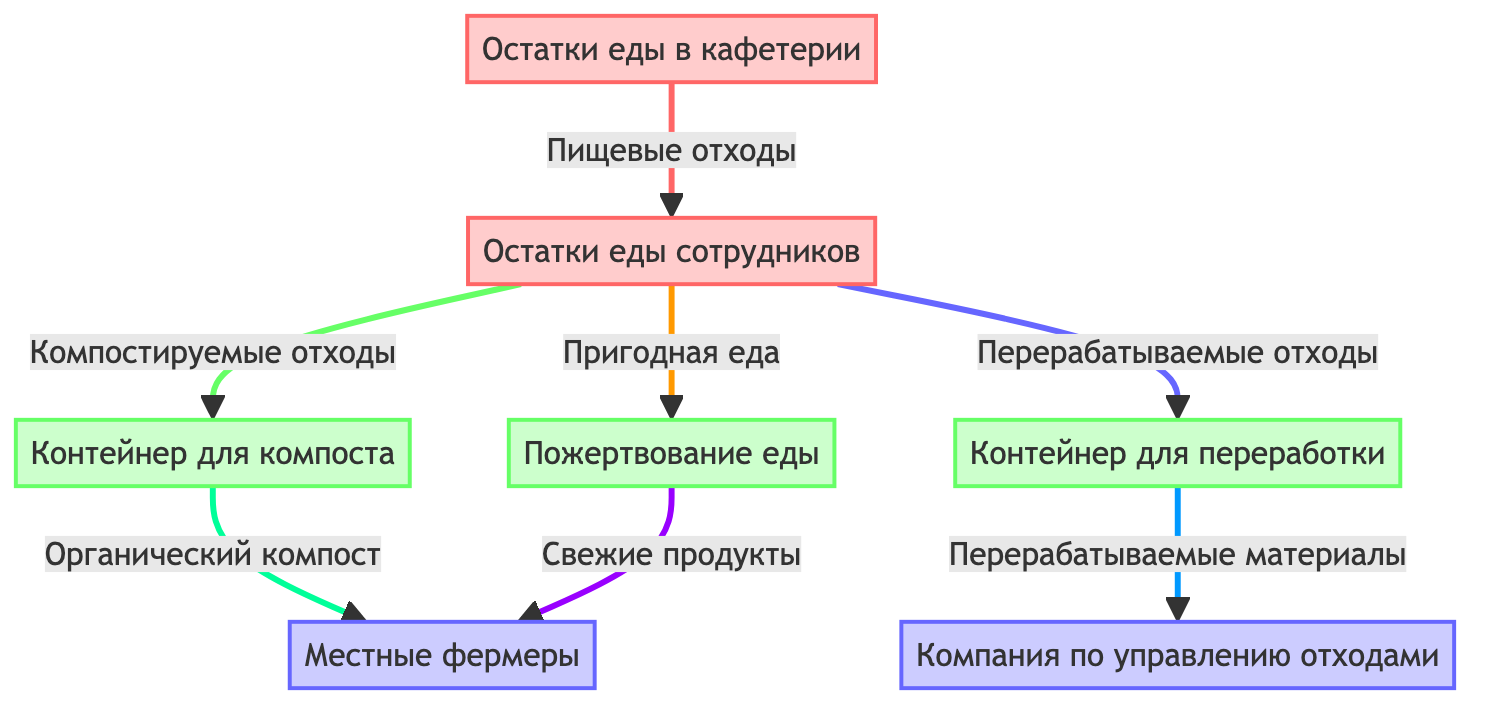What are the two main types of food waste in the diagram? The diagram shows two main types of food waste: cafeteria food waste and employee leftovers. These are represented as the first two nodes in the flowchart.
Answer: Остатки еды в кафетерии, Остатки еды сотрудников Which process handles the employee leftovers that are compostable? The diagram indicates that compostable employee leftovers go to the compost bin, which is specifically structured to process these types of waste.
Answer: Контейнер для компоста How many destinations are identified for waste in the diagram? In total, there are two destinations for waste shown in the diagram: local farmers and the waste management company. Each destination is connected to a different type of processed waste.
Answer: 2 What type of food waste is donated to local farmers? The food donation process specifically handles suitable food that can be donated to local farmers, as illustrated in the flowchart.
Answer: Пригодная еда What happens to the organic compost after being processed? The flowchart illustrates that organic compost from the compost bin is directed to local farmers, indicating that it is used beneficially rather than wasted.
Answer: Местные фермеры Which type of waste goes to the recycling bin? The diagram shows that employee leftovers classified as recyclable are sent to the recycling bin, where they are processed before reaching their next stage.
Answer: Перерабатываемые отходы What is the relationship between the compost bin and local farmers? The flowchart shows a direct link from the compost bin to local farmers, indicating that organic compost produced there is specifically directed to them for use.
Answer: Органический компост How many processes are involved in handling employee leftovers? The diagram represents three processes for handling employee leftovers: compost bin, recycling bin, and food donation, indicating multiple routes for waste management.
Answer: 3 